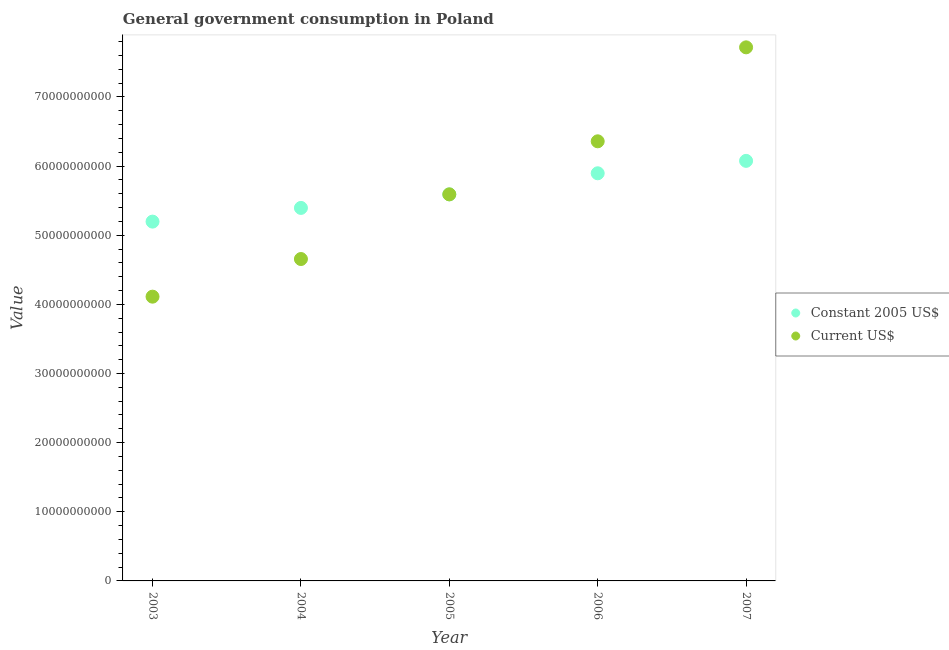Is the number of dotlines equal to the number of legend labels?
Keep it short and to the point. Yes. What is the value consumed in current us$ in 2005?
Provide a short and direct response. 5.59e+1. Across all years, what is the maximum value consumed in constant 2005 us$?
Provide a short and direct response. 6.08e+1. Across all years, what is the minimum value consumed in constant 2005 us$?
Your answer should be very brief. 5.20e+1. In which year was the value consumed in current us$ maximum?
Ensure brevity in your answer.  2007. In which year was the value consumed in current us$ minimum?
Your response must be concise. 2003. What is the total value consumed in constant 2005 us$ in the graph?
Your answer should be very brief. 2.82e+11. What is the difference between the value consumed in current us$ in 2005 and that in 2007?
Your answer should be very brief. -2.13e+1. What is the difference between the value consumed in current us$ in 2007 and the value consumed in constant 2005 us$ in 2005?
Keep it short and to the point. 2.13e+1. What is the average value consumed in current us$ per year?
Keep it short and to the point. 5.69e+1. In the year 2003, what is the difference between the value consumed in current us$ and value consumed in constant 2005 us$?
Your answer should be very brief. -1.09e+1. In how many years, is the value consumed in constant 2005 us$ greater than 56000000000?
Give a very brief answer. 2. What is the ratio of the value consumed in constant 2005 us$ in 2005 to that in 2007?
Make the answer very short. 0.92. Is the value consumed in constant 2005 us$ in 2004 less than that in 2007?
Offer a terse response. Yes. What is the difference between the highest and the second highest value consumed in constant 2005 us$?
Offer a very short reply. 1.80e+09. What is the difference between the highest and the lowest value consumed in constant 2005 us$?
Offer a terse response. 8.79e+09. Is the sum of the value consumed in current us$ in 2003 and 2004 greater than the maximum value consumed in constant 2005 us$ across all years?
Keep it short and to the point. Yes. What is the difference between two consecutive major ticks on the Y-axis?
Provide a short and direct response. 1.00e+1. What is the title of the graph?
Offer a very short reply. General government consumption in Poland. What is the label or title of the Y-axis?
Offer a terse response. Value. What is the Value in Constant 2005 US$ in 2003?
Provide a succinct answer. 5.20e+1. What is the Value of Current US$ in 2003?
Provide a succinct answer. 4.11e+1. What is the Value in Constant 2005 US$ in 2004?
Offer a terse response. 5.39e+1. What is the Value in Current US$ in 2004?
Your answer should be compact. 4.66e+1. What is the Value of Constant 2005 US$ in 2005?
Your answer should be very brief. 5.59e+1. What is the Value of Current US$ in 2005?
Provide a succinct answer. 5.59e+1. What is the Value in Constant 2005 US$ in 2006?
Give a very brief answer. 5.90e+1. What is the Value in Current US$ in 2006?
Offer a terse response. 6.36e+1. What is the Value in Constant 2005 US$ in 2007?
Offer a very short reply. 6.08e+1. What is the Value in Current US$ in 2007?
Keep it short and to the point. 7.72e+1. Across all years, what is the maximum Value in Constant 2005 US$?
Your answer should be compact. 6.08e+1. Across all years, what is the maximum Value of Current US$?
Your response must be concise. 7.72e+1. Across all years, what is the minimum Value of Constant 2005 US$?
Keep it short and to the point. 5.20e+1. Across all years, what is the minimum Value in Current US$?
Provide a succinct answer. 4.11e+1. What is the total Value of Constant 2005 US$ in the graph?
Make the answer very short. 2.82e+11. What is the total Value in Current US$ in the graph?
Your response must be concise. 2.84e+11. What is the difference between the Value of Constant 2005 US$ in 2003 and that in 2004?
Give a very brief answer. -1.98e+09. What is the difference between the Value of Current US$ in 2003 and that in 2004?
Your response must be concise. -5.44e+09. What is the difference between the Value in Constant 2005 US$ in 2003 and that in 2005?
Provide a succinct answer. -3.94e+09. What is the difference between the Value in Current US$ in 2003 and that in 2005?
Keep it short and to the point. -1.48e+1. What is the difference between the Value in Constant 2005 US$ in 2003 and that in 2006?
Your answer should be compact. -6.99e+09. What is the difference between the Value of Current US$ in 2003 and that in 2006?
Your response must be concise. -2.25e+1. What is the difference between the Value in Constant 2005 US$ in 2003 and that in 2007?
Give a very brief answer. -8.79e+09. What is the difference between the Value in Current US$ in 2003 and that in 2007?
Keep it short and to the point. -3.61e+1. What is the difference between the Value in Constant 2005 US$ in 2004 and that in 2005?
Give a very brief answer. -1.96e+09. What is the difference between the Value in Current US$ in 2004 and that in 2005?
Your answer should be very brief. -9.35e+09. What is the difference between the Value in Constant 2005 US$ in 2004 and that in 2006?
Keep it short and to the point. -5.01e+09. What is the difference between the Value in Current US$ in 2004 and that in 2006?
Your answer should be compact. -1.70e+1. What is the difference between the Value of Constant 2005 US$ in 2004 and that in 2007?
Offer a very short reply. -6.81e+09. What is the difference between the Value in Current US$ in 2004 and that in 2007?
Offer a very short reply. -3.06e+1. What is the difference between the Value of Constant 2005 US$ in 2005 and that in 2006?
Your answer should be compact. -3.05e+09. What is the difference between the Value of Current US$ in 2005 and that in 2006?
Provide a short and direct response. -7.67e+09. What is the difference between the Value in Constant 2005 US$ in 2005 and that in 2007?
Provide a short and direct response. -4.85e+09. What is the difference between the Value of Current US$ in 2005 and that in 2007?
Your response must be concise. -2.13e+1. What is the difference between the Value of Constant 2005 US$ in 2006 and that in 2007?
Ensure brevity in your answer.  -1.80e+09. What is the difference between the Value in Current US$ in 2006 and that in 2007?
Offer a very short reply. -1.36e+1. What is the difference between the Value of Constant 2005 US$ in 2003 and the Value of Current US$ in 2004?
Your answer should be compact. 5.41e+09. What is the difference between the Value of Constant 2005 US$ in 2003 and the Value of Current US$ in 2005?
Offer a terse response. -3.94e+09. What is the difference between the Value of Constant 2005 US$ in 2003 and the Value of Current US$ in 2006?
Give a very brief answer. -1.16e+1. What is the difference between the Value in Constant 2005 US$ in 2003 and the Value in Current US$ in 2007?
Offer a very short reply. -2.52e+1. What is the difference between the Value in Constant 2005 US$ in 2004 and the Value in Current US$ in 2005?
Give a very brief answer. -1.96e+09. What is the difference between the Value of Constant 2005 US$ in 2004 and the Value of Current US$ in 2006?
Offer a very short reply. -9.63e+09. What is the difference between the Value in Constant 2005 US$ in 2004 and the Value in Current US$ in 2007?
Keep it short and to the point. -2.32e+1. What is the difference between the Value of Constant 2005 US$ in 2005 and the Value of Current US$ in 2006?
Make the answer very short. -7.67e+09. What is the difference between the Value of Constant 2005 US$ in 2005 and the Value of Current US$ in 2007?
Ensure brevity in your answer.  -2.13e+1. What is the difference between the Value of Constant 2005 US$ in 2006 and the Value of Current US$ in 2007?
Your answer should be very brief. -1.82e+1. What is the average Value of Constant 2005 US$ per year?
Offer a very short reply. 5.63e+1. What is the average Value of Current US$ per year?
Make the answer very short. 5.69e+1. In the year 2003, what is the difference between the Value of Constant 2005 US$ and Value of Current US$?
Keep it short and to the point. 1.09e+1. In the year 2004, what is the difference between the Value of Constant 2005 US$ and Value of Current US$?
Make the answer very short. 7.39e+09. In the year 2005, what is the difference between the Value in Constant 2005 US$ and Value in Current US$?
Provide a succinct answer. 0. In the year 2006, what is the difference between the Value in Constant 2005 US$ and Value in Current US$?
Keep it short and to the point. -4.63e+09. In the year 2007, what is the difference between the Value in Constant 2005 US$ and Value in Current US$?
Ensure brevity in your answer.  -1.64e+1. What is the ratio of the Value of Constant 2005 US$ in 2003 to that in 2004?
Your answer should be compact. 0.96. What is the ratio of the Value in Current US$ in 2003 to that in 2004?
Provide a succinct answer. 0.88. What is the ratio of the Value in Constant 2005 US$ in 2003 to that in 2005?
Your response must be concise. 0.93. What is the ratio of the Value in Current US$ in 2003 to that in 2005?
Your response must be concise. 0.74. What is the ratio of the Value of Constant 2005 US$ in 2003 to that in 2006?
Ensure brevity in your answer.  0.88. What is the ratio of the Value of Current US$ in 2003 to that in 2006?
Make the answer very short. 0.65. What is the ratio of the Value in Constant 2005 US$ in 2003 to that in 2007?
Ensure brevity in your answer.  0.86. What is the ratio of the Value in Current US$ in 2003 to that in 2007?
Provide a short and direct response. 0.53. What is the ratio of the Value in Constant 2005 US$ in 2004 to that in 2005?
Your answer should be compact. 0.96. What is the ratio of the Value of Current US$ in 2004 to that in 2005?
Provide a short and direct response. 0.83. What is the ratio of the Value of Constant 2005 US$ in 2004 to that in 2006?
Offer a terse response. 0.92. What is the ratio of the Value in Current US$ in 2004 to that in 2006?
Keep it short and to the point. 0.73. What is the ratio of the Value in Constant 2005 US$ in 2004 to that in 2007?
Your answer should be very brief. 0.89. What is the ratio of the Value in Current US$ in 2004 to that in 2007?
Your answer should be compact. 0.6. What is the ratio of the Value of Constant 2005 US$ in 2005 to that in 2006?
Keep it short and to the point. 0.95. What is the ratio of the Value of Current US$ in 2005 to that in 2006?
Offer a terse response. 0.88. What is the ratio of the Value of Constant 2005 US$ in 2005 to that in 2007?
Keep it short and to the point. 0.92. What is the ratio of the Value in Current US$ in 2005 to that in 2007?
Keep it short and to the point. 0.72. What is the ratio of the Value in Constant 2005 US$ in 2006 to that in 2007?
Provide a succinct answer. 0.97. What is the ratio of the Value in Current US$ in 2006 to that in 2007?
Your answer should be compact. 0.82. What is the difference between the highest and the second highest Value of Constant 2005 US$?
Offer a very short reply. 1.80e+09. What is the difference between the highest and the second highest Value in Current US$?
Give a very brief answer. 1.36e+1. What is the difference between the highest and the lowest Value in Constant 2005 US$?
Your response must be concise. 8.79e+09. What is the difference between the highest and the lowest Value in Current US$?
Provide a succinct answer. 3.61e+1. 